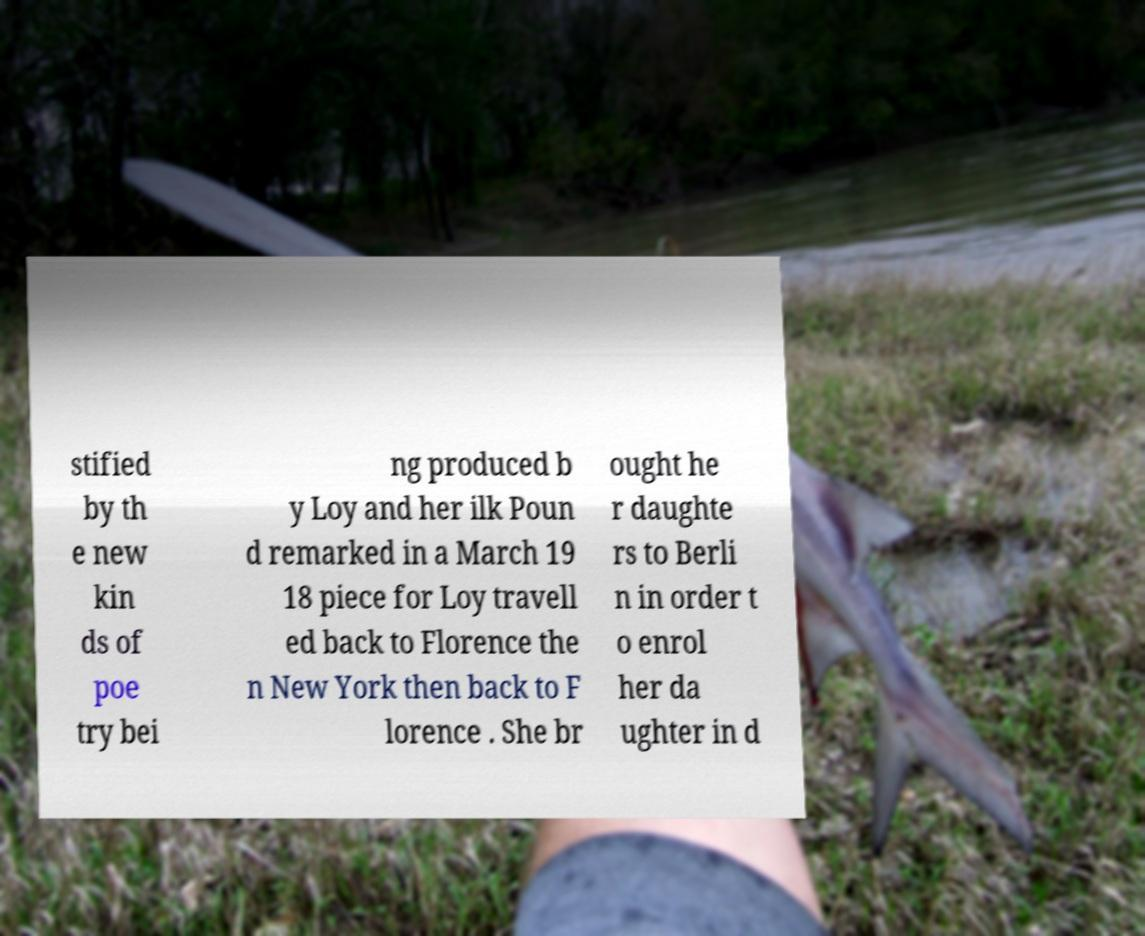For documentation purposes, I need the text within this image transcribed. Could you provide that? stified by th e new kin ds of poe try bei ng produced b y Loy and her ilk Poun d remarked in a March 19 18 piece for Loy travell ed back to Florence the n New York then back to F lorence . She br ought he r daughte rs to Berli n in order t o enrol her da ughter in d 